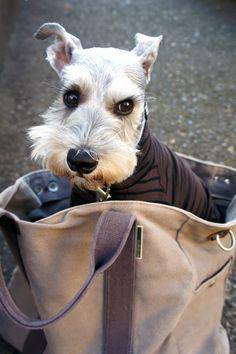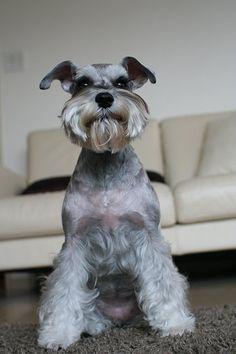The first image is the image on the left, the second image is the image on the right. Assess this claim about the two images: "One of the dogs is sitting in a bag.". Correct or not? Answer yes or no. Yes. The first image is the image on the left, the second image is the image on the right. Evaluate the accuracy of this statement regarding the images: "An image shows one schnauzer, which is wearing a printed bandana around its neck.". Is it true? Answer yes or no. No. 